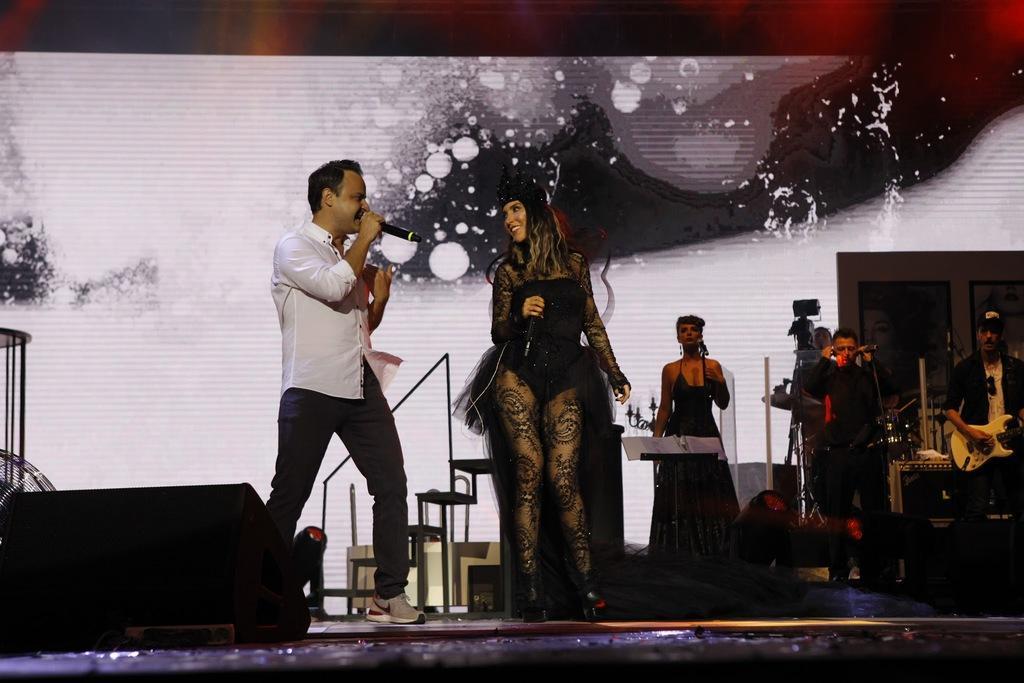Can you describe this image briefly? In this image I can see the group of people standing and wearing the different color dresses. I can see few people are holding the mics and few people are playing the musical instruments. In the background I can see the frames and the screen. 